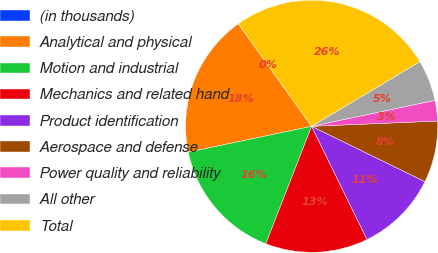<chart> <loc_0><loc_0><loc_500><loc_500><pie_chart><fcel>(in thousands)<fcel>Analytical and physical<fcel>Motion and industrial<fcel>Mechanics and related hand<fcel>Product identification<fcel>Aerospace and defense<fcel>Power quality and reliability<fcel>All other<fcel>Total<nl><fcel>0.01%<fcel>18.42%<fcel>15.79%<fcel>13.16%<fcel>10.53%<fcel>7.9%<fcel>2.64%<fcel>5.27%<fcel>26.31%<nl></chart> 